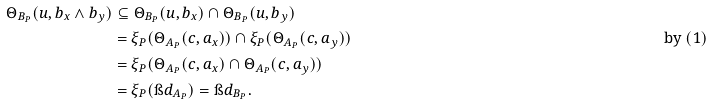Convert formula to latex. <formula><loc_0><loc_0><loc_500><loc_500>\Theta _ { B _ { P } } ( u , b _ { x } \wedge b _ { y } ) & \subseteq \Theta _ { B _ { P } } ( u , b _ { x } ) \cap \Theta _ { B _ { P } } ( u , b _ { y } ) \\ & = \xi _ { P } ( \Theta _ { A _ { P } } ( c , a _ { x } ) ) \cap \xi _ { P } ( \Theta _ { A _ { P } } ( c , a _ { y } ) ) & \text {by $(1)$} \\ & = \xi _ { P } ( \Theta _ { A _ { P } } ( c , a _ { x } ) \cap \Theta _ { A _ { P } } ( c , a _ { y } ) ) \\ & = \xi _ { P } ( \i d _ { A _ { P } } ) = \i d _ { B _ { P } } .</formula> 